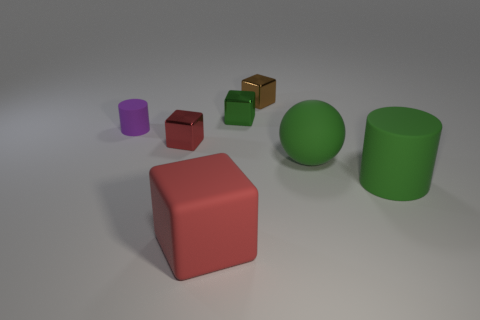There is a green matte ball; are there any green things left of it?
Give a very brief answer. Yes. What is the shape of the tiny metal thing that is the same color as the sphere?
Provide a short and direct response. Cube. How many objects are either small cubes that are in front of the tiny purple matte cylinder or small red metallic cubes?
Make the answer very short. 1. There is a brown block that is the same material as the tiny green thing; what size is it?
Give a very brief answer. Small. Is the size of the green matte sphere the same as the metallic cube in front of the tiny green block?
Provide a succinct answer. No. There is a matte thing that is on the left side of the brown block and in front of the tiny purple matte object; what color is it?
Your response must be concise. Red. What number of things are either matte things to the left of the big green sphere or tiny blocks that are on the right side of the large red object?
Your answer should be very brief. 4. The metal block that is left of the red cube that is on the right side of the small cube that is in front of the small green metal block is what color?
Keep it short and to the point. Red. Are there any purple matte things of the same shape as the brown object?
Give a very brief answer. No. What number of small cylinders are there?
Make the answer very short. 1. 